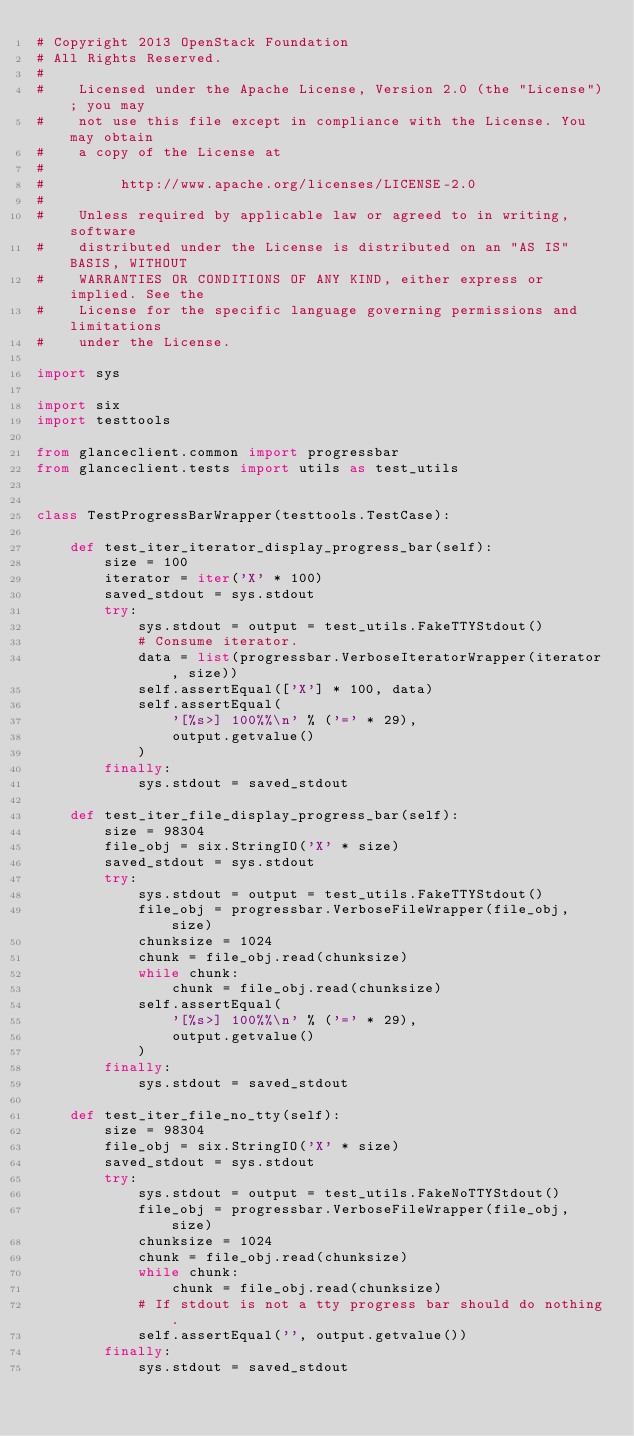<code> <loc_0><loc_0><loc_500><loc_500><_Python_># Copyright 2013 OpenStack Foundation
# All Rights Reserved.
#
#    Licensed under the Apache License, Version 2.0 (the "License"); you may
#    not use this file except in compliance with the License. You may obtain
#    a copy of the License at
#
#         http://www.apache.org/licenses/LICENSE-2.0
#
#    Unless required by applicable law or agreed to in writing, software
#    distributed under the License is distributed on an "AS IS" BASIS, WITHOUT
#    WARRANTIES OR CONDITIONS OF ANY KIND, either express or implied. See the
#    License for the specific language governing permissions and limitations
#    under the License.

import sys

import six
import testtools

from glanceclient.common import progressbar
from glanceclient.tests import utils as test_utils


class TestProgressBarWrapper(testtools.TestCase):

    def test_iter_iterator_display_progress_bar(self):
        size = 100
        iterator = iter('X' * 100)
        saved_stdout = sys.stdout
        try:
            sys.stdout = output = test_utils.FakeTTYStdout()
            # Consume iterator.
            data = list(progressbar.VerboseIteratorWrapper(iterator, size))
            self.assertEqual(['X'] * 100, data)
            self.assertEqual(
                '[%s>] 100%%\n' % ('=' * 29),
                output.getvalue()
            )
        finally:
            sys.stdout = saved_stdout

    def test_iter_file_display_progress_bar(self):
        size = 98304
        file_obj = six.StringIO('X' * size)
        saved_stdout = sys.stdout
        try:
            sys.stdout = output = test_utils.FakeTTYStdout()
            file_obj = progressbar.VerboseFileWrapper(file_obj, size)
            chunksize = 1024
            chunk = file_obj.read(chunksize)
            while chunk:
                chunk = file_obj.read(chunksize)
            self.assertEqual(
                '[%s>] 100%%\n' % ('=' * 29),
                output.getvalue()
            )
        finally:
            sys.stdout = saved_stdout

    def test_iter_file_no_tty(self):
        size = 98304
        file_obj = six.StringIO('X' * size)
        saved_stdout = sys.stdout
        try:
            sys.stdout = output = test_utils.FakeNoTTYStdout()
            file_obj = progressbar.VerboseFileWrapper(file_obj, size)
            chunksize = 1024
            chunk = file_obj.read(chunksize)
            while chunk:
                chunk = file_obj.read(chunksize)
            # If stdout is not a tty progress bar should do nothing.
            self.assertEqual('', output.getvalue())
        finally:
            sys.stdout = saved_stdout
</code> 